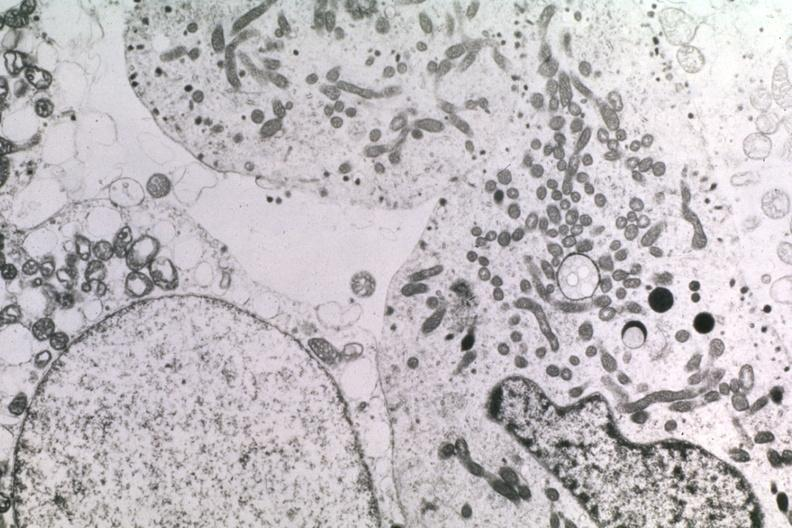what is present?
Answer the question using a single word or phrase. Endocrine 